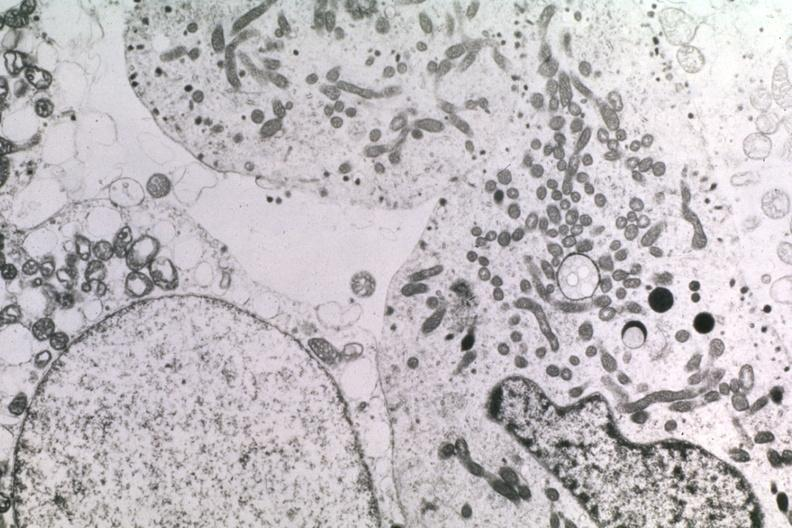what is present?
Answer the question using a single word or phrase. Endocrine 